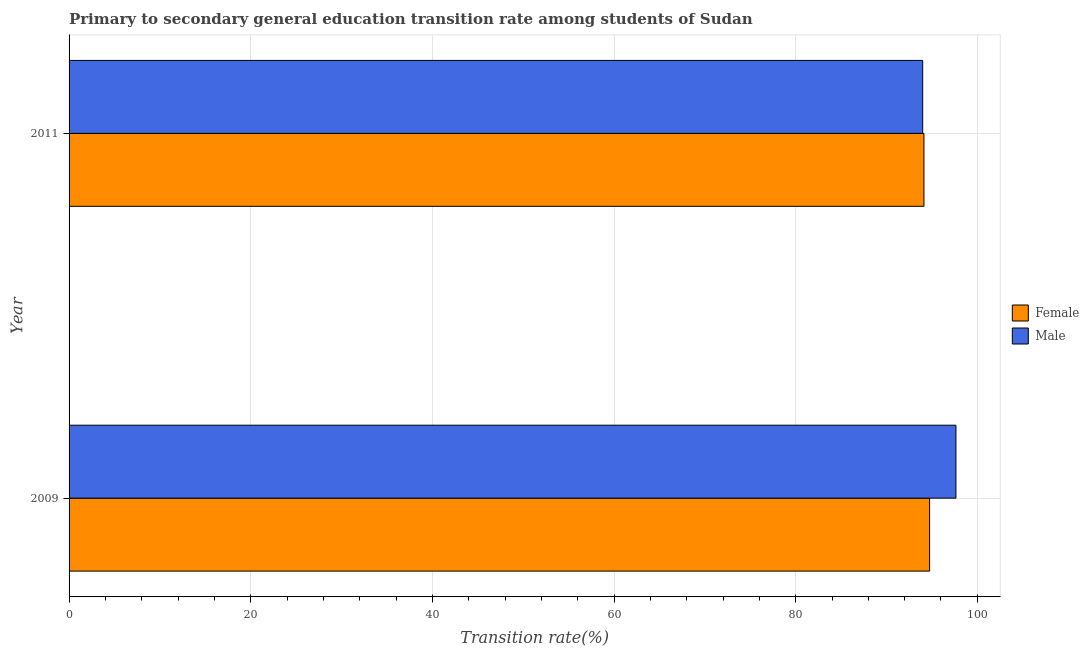How many different coloured bars are there?
Make the answer very short. 2. Are the number of bars per tick equal to the number of legend labels?
Give a very brief answer. Yes. Are the number of bars on each tick of the Y-axis equal?
Provide a short and direct response. Yes. What is the transition rate among male students in 2009?
Ensure brevity in your answer.  97.65. Across all years, what is the maximum transition rate among female students?
Your answer should be compact. 94.75. Across all years, what is the minimum transition rate among male students?
Give a very brief answer. 93.98. In which year was the transition rate among male students maximum?
Keep it short and to the point. 2009. What is the total transition rate among female students in the graph?
Make the answer very short. 188.87. What is the difference between the transition rate among male students in 2009 and that in 2011?
Provide a short and direct response. 3.66. What is the difference between the transition rate among male students in 2009 and the transition rate among female students in 2011?
Your response must be concise. 3.52. What is the average transition rate among male students per year?
Your answer should be very brief. 95.82. In the year 2011, what is the difference between the transition rate among female students and transition rate among male students?
Offer a very short reply. 0.14. What is the ratio of the transition rate among female students in 2009 to that in 2011?
Your answer should be compact. 1.01. Is the difference between the transition rate among male students in 2009 and 2011 greater than the difference between the transition rate among female students in 2009 and 2011?
Offer a terse response. Yes. What does the 2nd bar from the top in 2011 represents?
Ensure brevity in your answer.  Female. How many bars are there?
Offer a terse response. 4. Are all the bars in the graph horizontal?
Give a very brief answer. Yes. What is the difference between two consecutive major ticks on the X-axis?
Offer a very short reply. 20. How are the legend labels stacked?
Provide a short and direct response. Vertical. What is the title of the graph?
Your response must be concise. Primary to secondary general education transition rate among students of Sudan. What is the label or title of the X-axis?
Provide a short and direct response. Transition rate(%). What is the Transition rate(%) of Female in 2009?
Make the answer very short. 94.75. What is the Transition rate(%) in Male in 2009?
Your response must be concise. 97.65. What is the Transition rate(%) of Female in 2011?
Your response must be concise. 94.13. What is the Transition rate(%) in Male in 2011?
Ensure brevity in your answer.  93.98. Across all years, what is the maximum Transition rate(%) of Female?
Make the answer very short. 94.75. Across all years, what is the maximum Transition rate(%) of Male?
Your answer should be very brief. 97.65. Across all years, what is the minimum Transition rate(%) in Female?
Provide a succinct answer. 94.13. Across all years, what is the minimum Transition rate(%) of Male?
Make the answer very short. 93.98. What is the total Transition rate(%) in Female in the graph?
Your answer should be very brief. 188.87. What is the total Transition rate(%) in Male in the graph?
Make the answer very short. 191.63. What is the difference between the Transition rate(%) of Female in 2009 and that in 2011?
Your response must be concise. 0.62. What is the difference between the Transition rate(%) of Male in 2009 and that in 2011?
Your answer should be compact. 3.66. What is the difference between the Transition rate(%) in Female in 2009 and the Transition rate(%) in Male in 2011?
Your response must be concise. 0.76. What is the average Transition rate(%) in Female per year?
Your answer should be very brief. 94.44. What is the average Transition rate(%) in Male per year?
Provide a short and direct response. 95.82. In the year 2009, what is the difference between the Transition rate(%) of Female and Transition rate(%) of Male?
Ensure brevity in your answer.  -2.9. In the year 2011, what is the difference between the Transition rate(%) of Female and Transition rate(%) of Male?
Your answer should be compact. 0.14. What is the ratio of the Transition rate(%) in Female in 2009 to that in 2011?
Offer a very short reply. 1.01. What is the ratio of the Transition rate(%) in Male in 2009 to that in 2011?
Give a very brief answer. 1.04. What is the difference between the highest and the second highest Transition rate(%) of Female?
Provide a short and direct response. 0.62. What is the difference between the highest and the second highest Transition rate(%) of Male?
Provide a short and direct response. 3.66. What is the difference between the highest and the lowest Transition rate(%) of Female?
Provide a short and direct response. 0.62. What is the difference between the highest and the lowest Transition rate(%) of Male?
Keep it short and to the point. 3.66. 